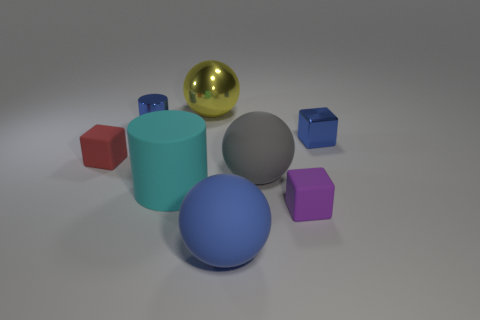Subtract all tiny matte blocks. How many blocks are left? 1 Add 2 red blocks. How many objects exist? 10 Subtract 2 spheres. How many spheres are left? 1 Subtract all purple cubes. How many cubes are left? 2 Subtract all balls. How many objects are left? 5 Add 3 blue cylinders. How many blue cylinders are left? 4 Add 6 big purple metallic blocks. How many big purple metallic blocks exist? 6 Subtract 0 purple balls. How many objects are left? 8 Subtract all cyan balls. Subtract all brown cubes. How many balls are left? 3 Subtract all red cylinders. How many yellow spheres are left? 1 